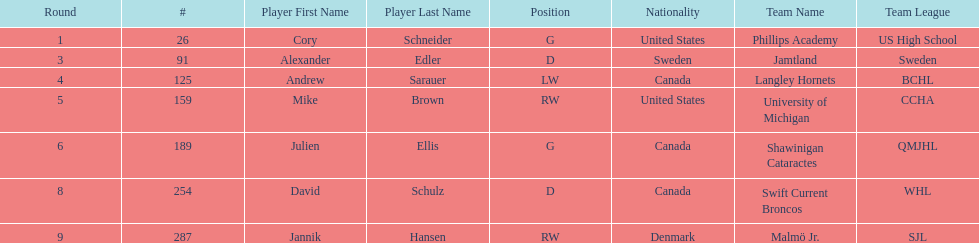Which players are not from denmark? Cory Schneider (G), Alexander Edler (D), Andrew Sarauer (LW), Mike Brown (RW), Julien Ellis (G), David Schulz (D). 